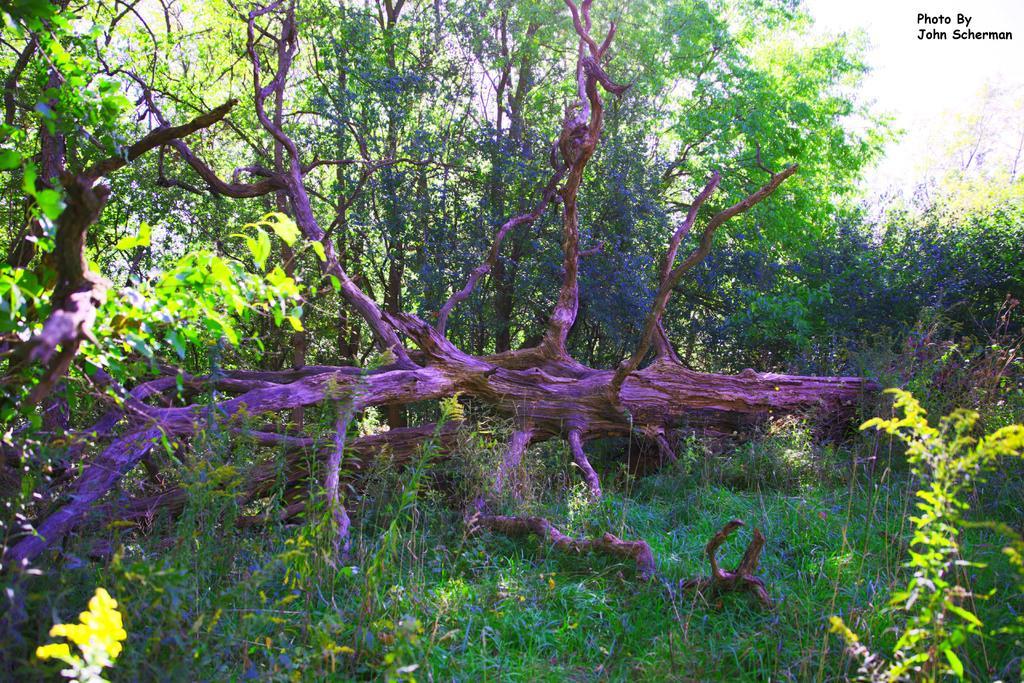Can you describe this image briefly? In the picture we can see grass plants, plants and some tree branch on it with a blue color light focus on it and behind it we can see plants, trees and sky. 